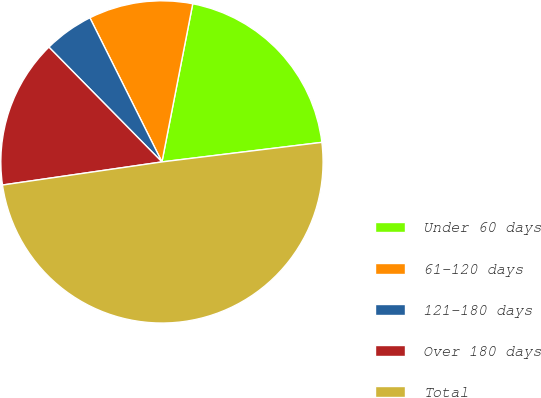Convert chart to OTSL. <chart><loc_0><loc_0><loc_500><loc_500><pie_chart><fcel>Under 60 days<fcel>61-120 days<fcel>121-180 days<fcel>Over 180 days<fcel>Total<nl><fcel>20.0%<fcel>10.44%<fcel>5.0%<fcel>14.91%<fcel>49.64%<nl></chart> 